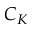<formula> <loc_0><loc_0><loc_500><loc_500>C _ { K }</formula> 